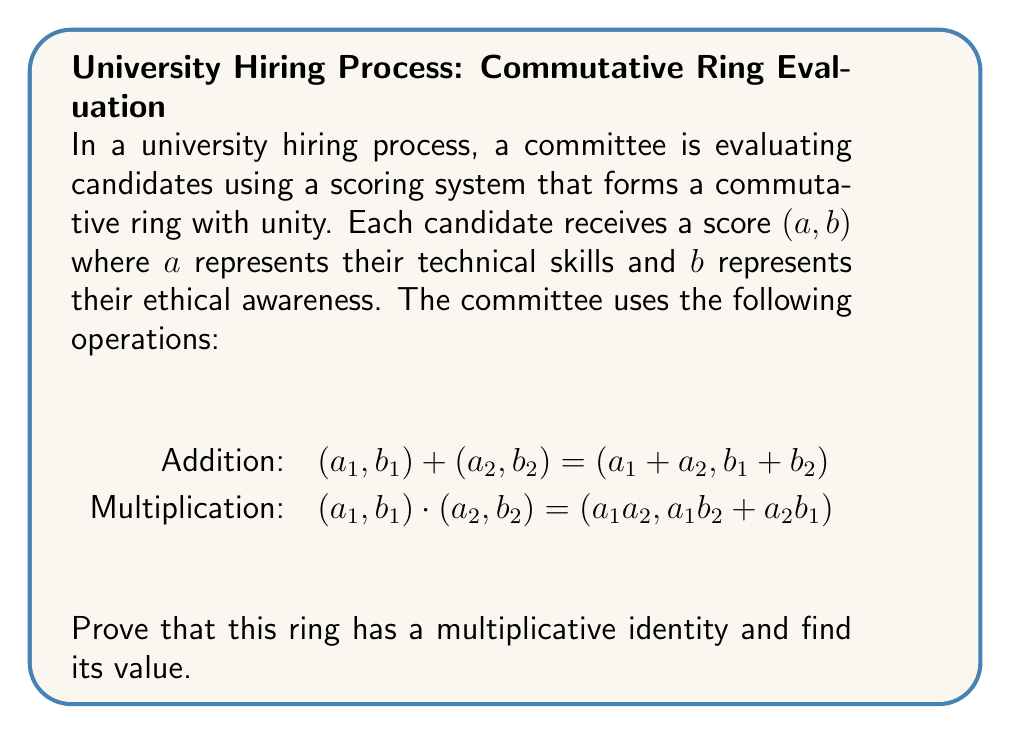Solve this math problem. To prove the existence of a multiplicative identity in this commutative ring with unity, we need to find an element $(e,f)$ such that for any element $(a,b)$ in the ring:

$(e,f) \cdot (a,b) = (a,b) \cdot (e,f) = (a,b)$

Let's break this down step-by-step:

1) Using the given multiplication operation:
   $(e,f) \cdot (a,b) = (ea, eb + fa)$

2) For this to be equal to $(a,b)$ for all $(a,b)$, we must have:
   $ea = a$ and $eb + fa = b$

3) From $ea = a$, we can conclude that $e = 1$ (as this must hold for all $a$)

4) Substituting $e = 1$ into $eb + fa = b$:
   $b + fa = b$
   
5) This implies that $fa = 0$ for all $a$, which is only possible if $f = 0$

6) Therefore, the multiplicative identity must be $(1,0)$

To verify:
$(1,0) \cdot (a,b) = (1a, 1b + 0a) = (a,b)$

This proves that $(1,0)$ is indeed the multiplicative identity in this ring.
Answer: The multiplicative identity is $(1,0)$. 